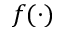Convert formula to latex. <formula><loc_0><loc_0><loc_500><loc_500>f ( \cdot )</formula> 